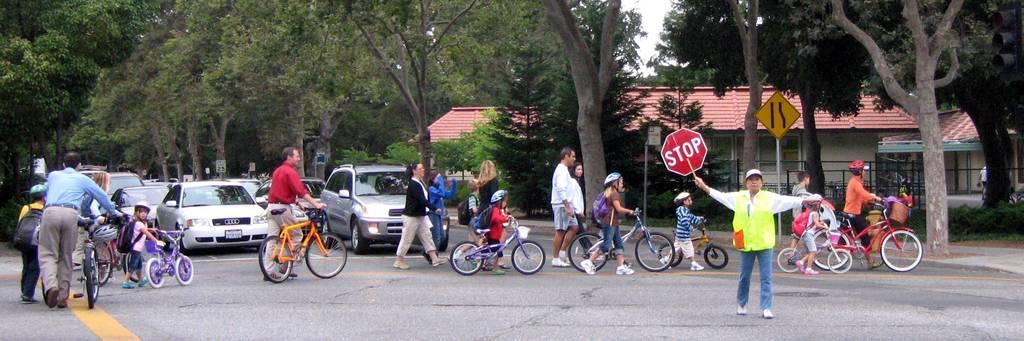Please provide a concise description of this image. In this image there are group of people and in the middle of the image there is a person with green shirt and holding a board and at the back there are group of people crossing the road, there are many vehicles on the road, there is a building behind the trees. 